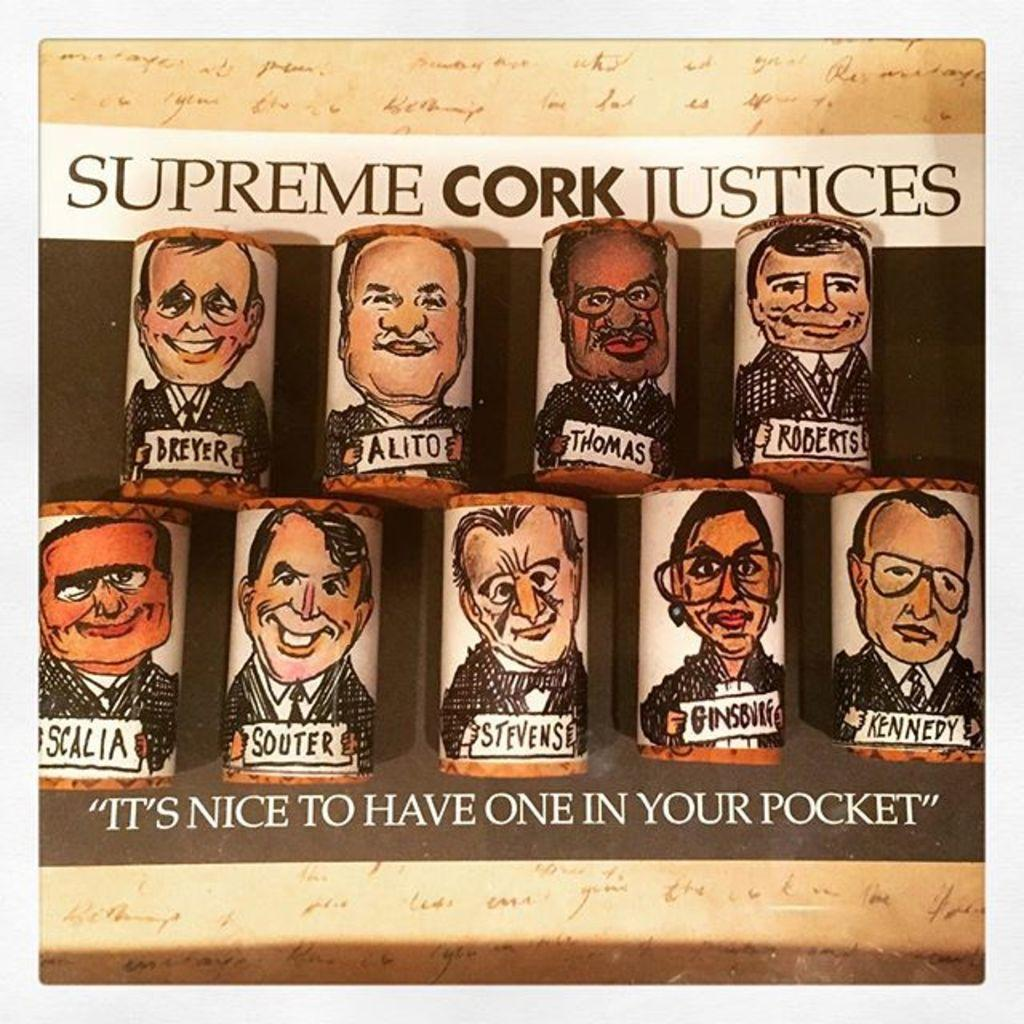What type of images are present in the image? There are animated images in the image. Are there any words or letters in the image? Yes, there is text in the image. Can you see a wren perched on the animated character's shoulder in the image? There is no wren present in the image. What story is being told through the animated images in the image? The image does not depict a specific story; it simply contains animated images and text. 